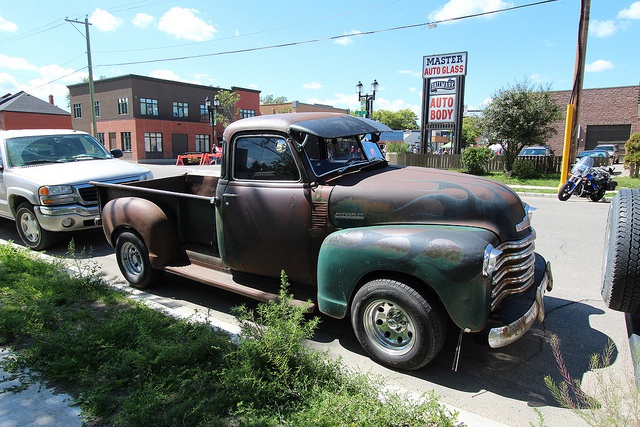Describe the objects in this image and their specific colors. I can see truck in lightblue, black, gray, darkgray, and lightgray tones, truck in lightblue, white, black, gray, and blue tones, car in lightblue, black, darkgray, gray, and lightgray tones, motorcycle in lightblue, black, gray, lavender, and darkgray tones, and car in lightblue, gray, darkgray, black, and blue tones in this image. 